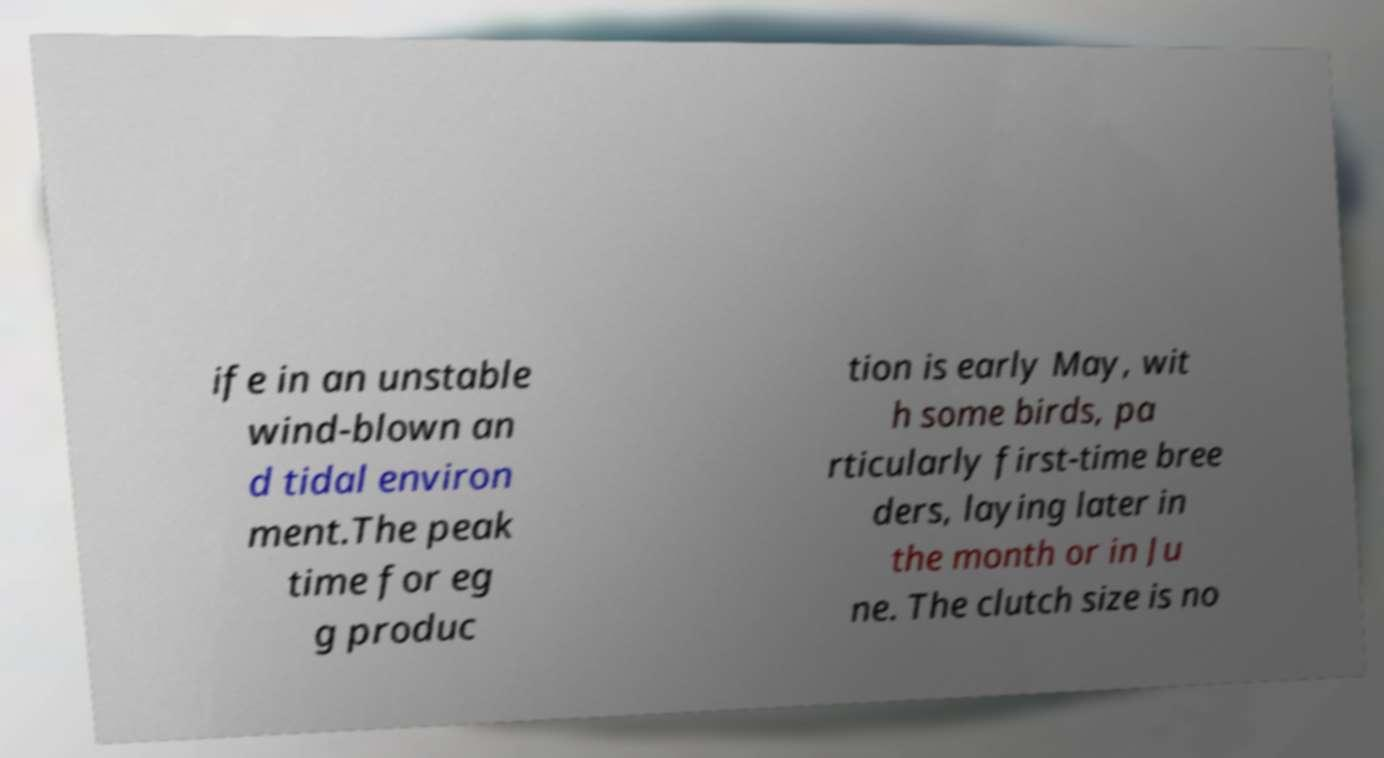Please read and relay the text visible in this image. What does it say? ife in an unstable wind-blown an d tidal environ ment.The peak time for eg g produc tion is early May, wit h some birds, pa rticularly first-time bree ders, laying later in the month or in Ju ne. The clutch size is no 